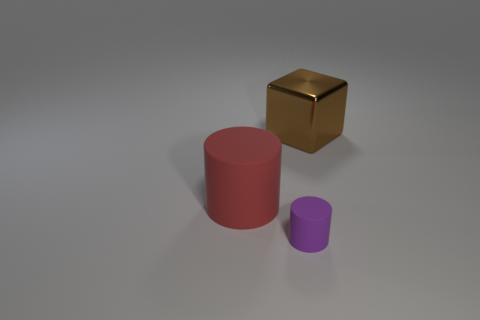The thing that is to the right of the large red cylinder and in front of the large brown cube has what shape?
Provide a short and direct response. Cylinder. What size is the purple matte object that is the same shape as the large red object?
Provide a short and direct response. Small. Are there fewer purple matte cylinders that are to the left of the tiny cylinder than cylinders?
Your answer should be compact. Yes. There is a matte cylinder that is to the right of the big matte thing; what is its size?
Provide a succinct answer. Small. There is a large rubber thing that is the same shape as the small rubber object; what color is it?
Provide a succinct answer. Red. Is there anything else that is the same shape as the purple thing?
Offer a very short reply. Yes. There is a matte cylinder that is behind the tiny purple matte cylinder that is to the right of the large red rubber thing; is there a big metal thing on the left side of it?
Keep it short and to the point. No. How many cylinders have the same material as the tiny thing?
Your response must be concise. 1. Do the rubber object to the right of the large cylinder and the thing that is behind the big cylinder have the same size?
Make the answer very short. No. There is a rubber thing that is behind the rubber thing that is on the right side of the large thing that is on the left side of the big cube; what is its color?
Provide a short and direct response. Red. 